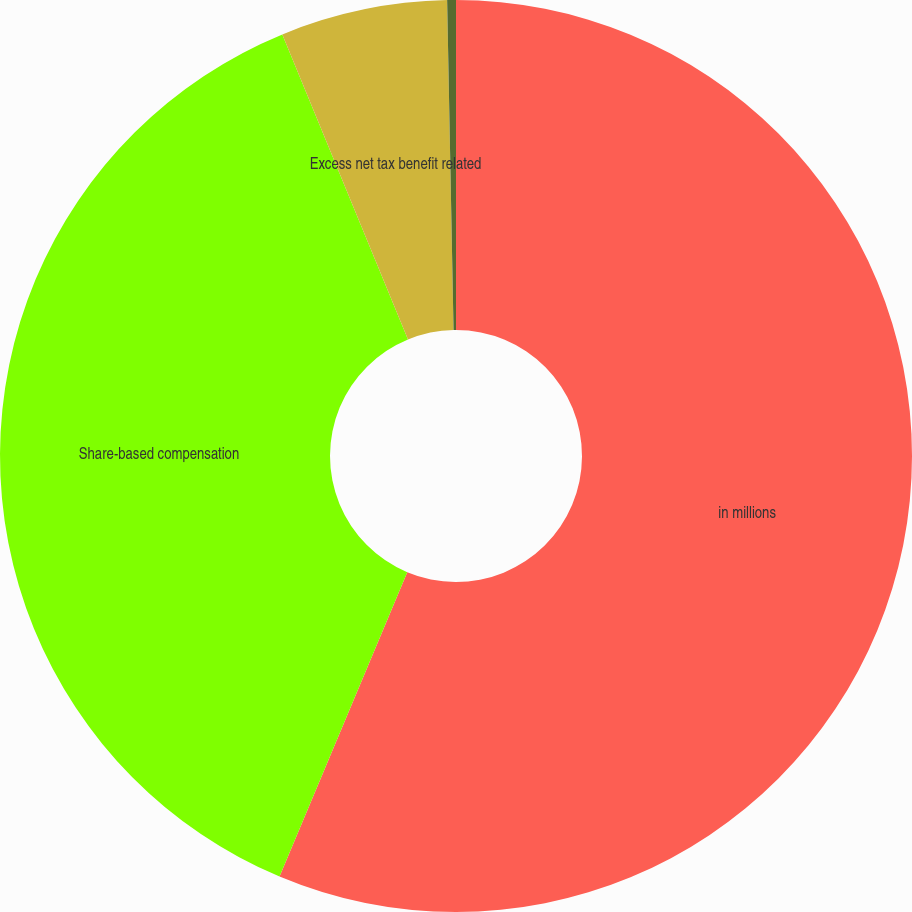<chart> <loc_0><loc_0><loc_500><loc_500><pie_chart><fcel>in millions<fcel>Share-based compensation<fcel>Excess net tax benefit related<fcel>Excess net tax<nl><fcel>56.33%<fcel>37.46%<fcel>5.91%<fcel>0.31%<nl></chart> 